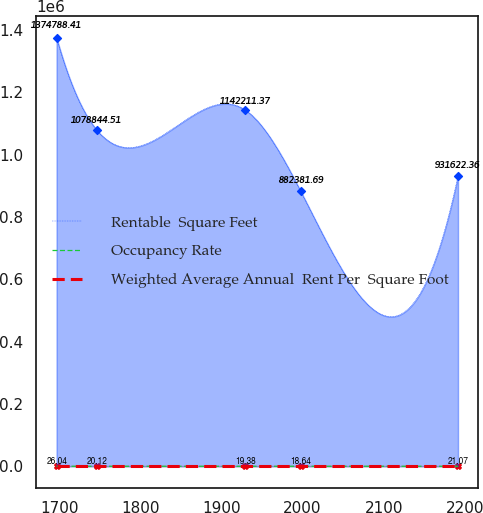Convert chart to OTSL. <chart><loc_0><loc_0><loc_500><loc_500><line_chart><ecel><fcel>Rentable  Square Feet<fcel>Occupancy Rate<fcel>Weighted Average Annual  Rent Per  Square Foot<nl><fcel>1696.89<fcel>1.37479e+06<fcel>81.81<fcel>26.04<nl><fcel>1746.36<fcel>1.07884e+06<fcel>97.22<fcel>20.12<nl><fcel>1929.68<fcel>1.14221e+06<fcel>95.39<fcel>19.38<nl><fcel>1997.69<fcel>882382<fcel>77.86<fcel>18.64<nl><fcel>2191.57<fcel>931622<fcel>79.69<fcel>21.07<nl></chart> 